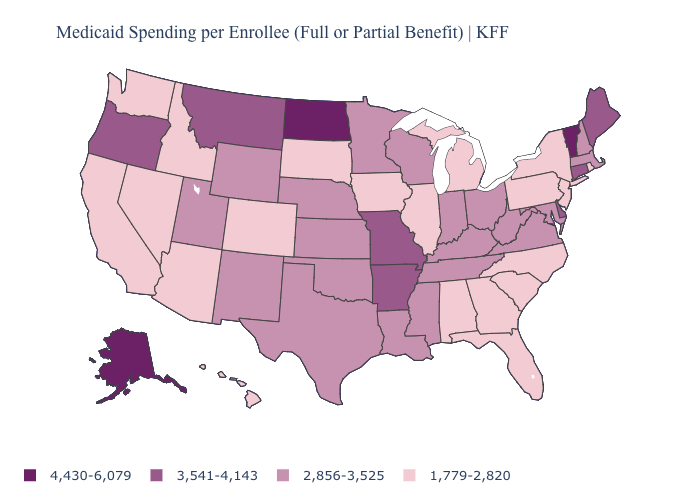Does Minnesota have a lower value than Connecticut?
Quick response, please. Yes. Which states have the lowest value in the USA?
Answer briefly. Alabama, Arizona, California, Colorado, Florida, Georgia, Hawaii, Idaho, Illinois, Iowa, Michigan, Nevada, New Jersey, New York, North Carolina, Pennsylvania, Rhode Island, South Carolina, South Dakota, Washington. Does Alaska have the highest value in the USA?
Answer briefly. Yes. What is the value of New Hampshire?
Give a very brief answer. 2,856-3,525. What is the lowest value in states that border Iowa?
Give a very brief answer. 1,779-2,820. What is the lowest value in states that border Pennsylvania?
Quick response, please. 1,779-2,820. What is the value of Missouri?
Write a very short answer. 3,541-4,143. Name the states that have a value in the range 1,779-2,820?
Quick response, please. Alabama, Arizona, California, Colorado, Florida, Georgia, Hawaii, Idaho, Illinois, Iowa, Michigan, Nevada, New Jersey, New York, North Carolina, Pennsylvania, Rhode Island, South Carolina, South Dakota, Washington. What is the value of Oklahoma?
Quick response, please. 2,856-3,525. Does the map have missing data?
Answer briefly. No. Name the states that have a value in the range 1,779-2,820?
Be succinct. Alabama, Arizona, California, Colorado, Florida, Georgia, Hawaii, Idaho, Illinois, Iowa, Michigan, Nevada, New Jersey, New York, North Carolina, Pennsylvania, Rhode Island, South Carolina, South Dakota, Washington. Does Minnesota have the lowest value in the MidWest?
Concise answer only. No. Does Virginia have the lowest value in the USA?
Be succinct. No. What is the value of Washington?
Concise answer only. 1,779-2,820. Does the first symbol in the legend represent the smallest category?
Write a very short answer. No. 